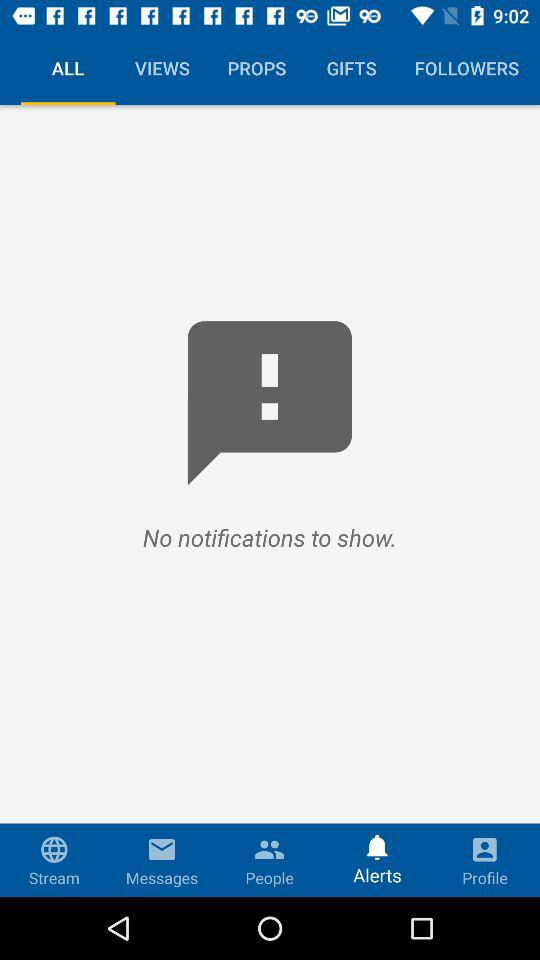Which tab is selected? The selected tabs are "ALL" and "Alerts". 